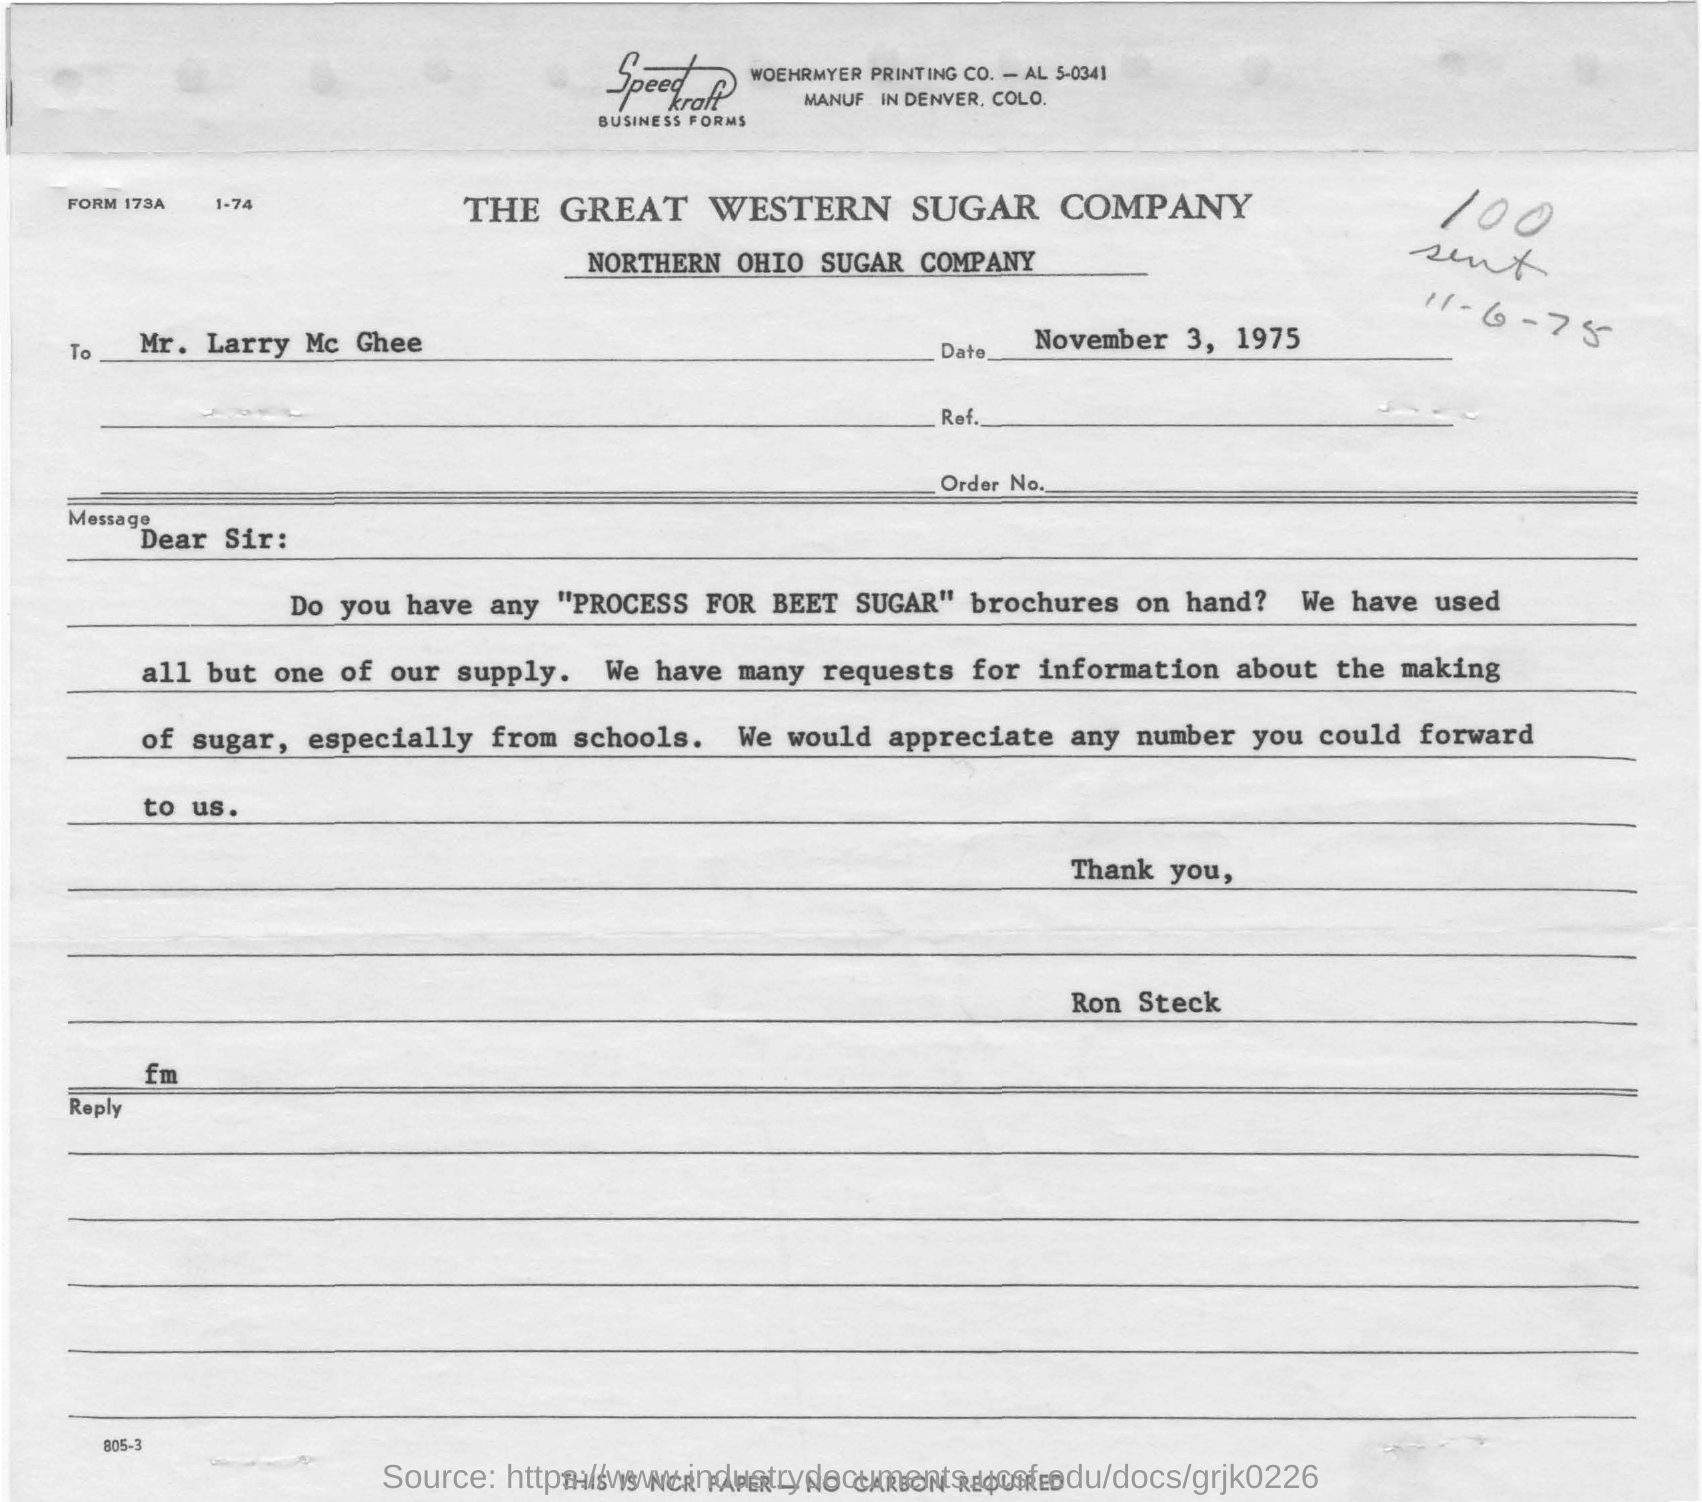What is 'PROCESS FOR BEET SUGAR' and why might there be a high demand for this information from schools? The 'PROCESS FOR BEET SUGAR' refers to educational material, likely a brochure, that details the methods involved in producing sugar from sugar beets. There's high demand for this information from schools probably because it's used in educational curriculum to teach students about agriculture, chemistry, and industrial processes related to the food industry. 